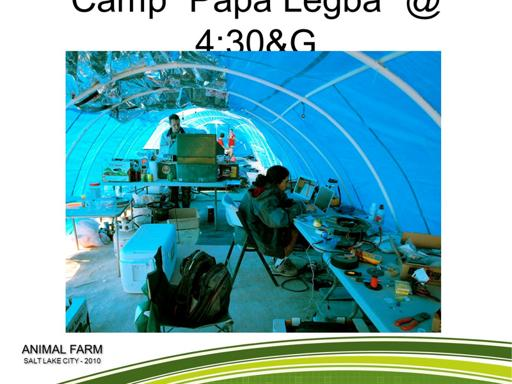What time does the event start? The event starts at 4:30 PM. This specific timing allows participants to gather during the late afternoon, possibly to take advantage of cooler temperatures and extended daylight. 